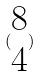Convert formula to latex. <formula><loc_0><loc_0><loc_500><loc_500>( \begin{matrix} 8 \\ 4 \end{matrix} )</formula> 